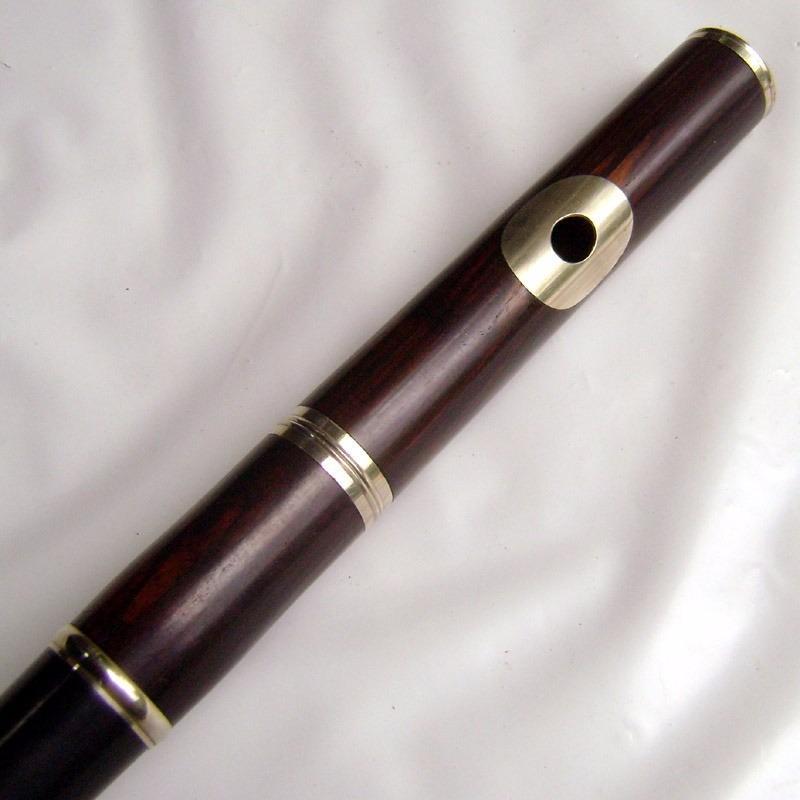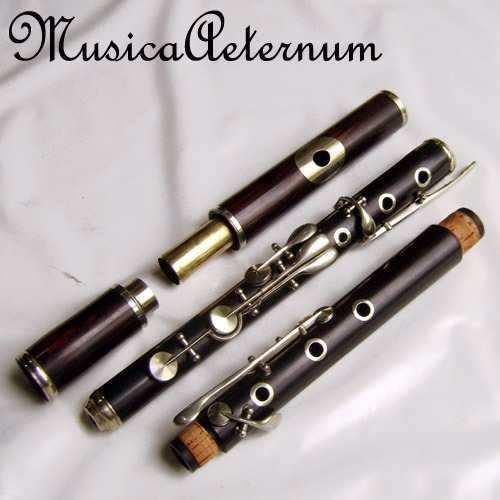The first image is the image on the left, the second image is the image on the right. Assess this claim about the two images: "One image contains at least three flute pieces displayed in a diagonal, non-touching row, and the other image features one diagonal tube shape with a single hole on its surface.". Correct or not? Answer yes or no. Yes. 